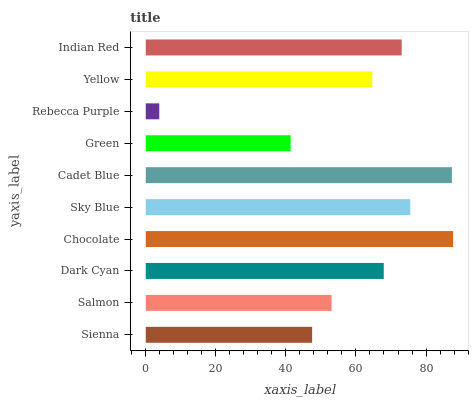Is Rebecca Purple the minimum?
Answer yes or no. Yes. Is Chocolate the maximum?
Answer yes or no. Yes. Is Salmon the minimum?
Answer yes or no. No. Is Salmon the maximum?
Answer yes or no. No. Is Salmon greater than Sienna?
Answer yes or no. Yes. Is Sienna less than Salmon?
Answer yes or no. Yes. Is Sienna greater than Salmon?
Answer yes or no. No. Is Salmon less than Sienna?
Answer yes or no. No. Is Dark Cyan the high median?
Answer yes or no. Yes. Is Yellow the low median?
Answer yes or no. Yes. Is Chocolate the high median?
Answer yes or no. No. Is Chocolate the low median?
Answer yes or no. No. 